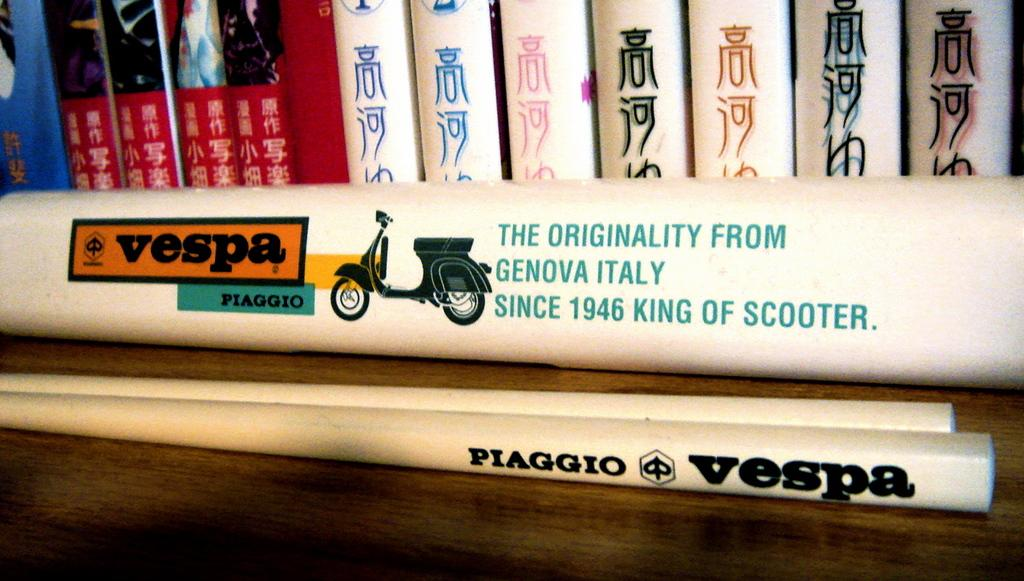<image>
Render a clear and concise summary of the photo. A horizontal image of a scooter is shown with the text "Vespa Fiaggio." 